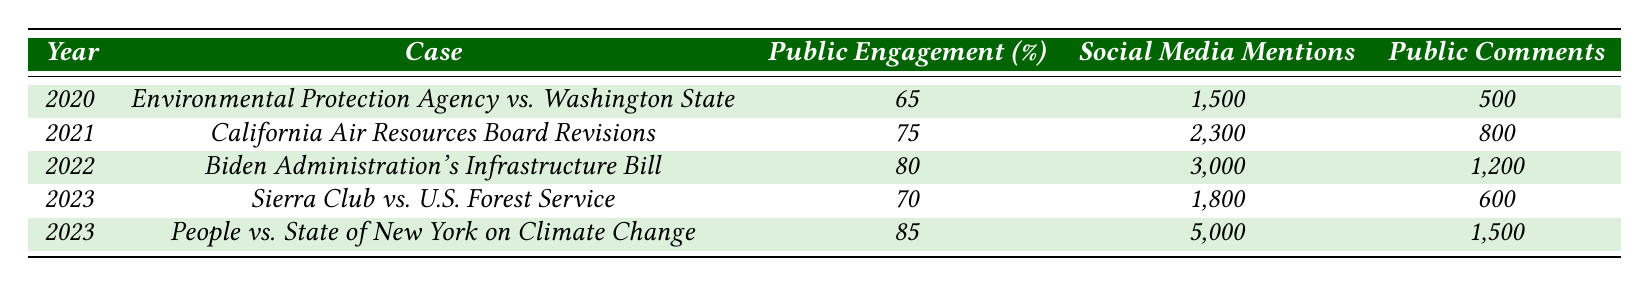What was the public engagement percentage for the case "Biden Administration's Infrastructure Bill"? According to the table, the public engagement percentage for the case "Biden Administration's Infrastructure Bill" in 2022 is 80%.
Answer: 80% Which case had the highest number of social media mentions? By examining the social media mentions column, the case "People vs. State of New York on Climate Change" in 2023 had the highest number of mentions with 5,000.
Answer: People vs. State of New York on Climate Change What is the average public engagement percentage for the years provided in the table? To find the average, add the public engagement percentages: 65 + 75 + 80 + 70 + 85 = 375. There are 5 years, so divide 375 by 5 to get an average of 75.
Answer: 75 Did the public engagement percentage increase from 2020 to 2023 for the case "California Air Resources Board Revisions"? The public engagement percentage for 2020 is 65%, and for 2023 it is 70%. Since 70% is not greater than 65%, the percentage did not increase.
Answer: No What can we conclude about the trend in public engagement percentages from 2020 to 2023? Reviewing the table, public engagement percentages started at 65% in 2020, increased to 75% in 2021, continued to rise to 80% in 2022, and fluctuated to 70% in one case and peaked at 85% in another in 2023. This indicates an overall increase with some variability.
Answer: Generally increasing with fluctuations 